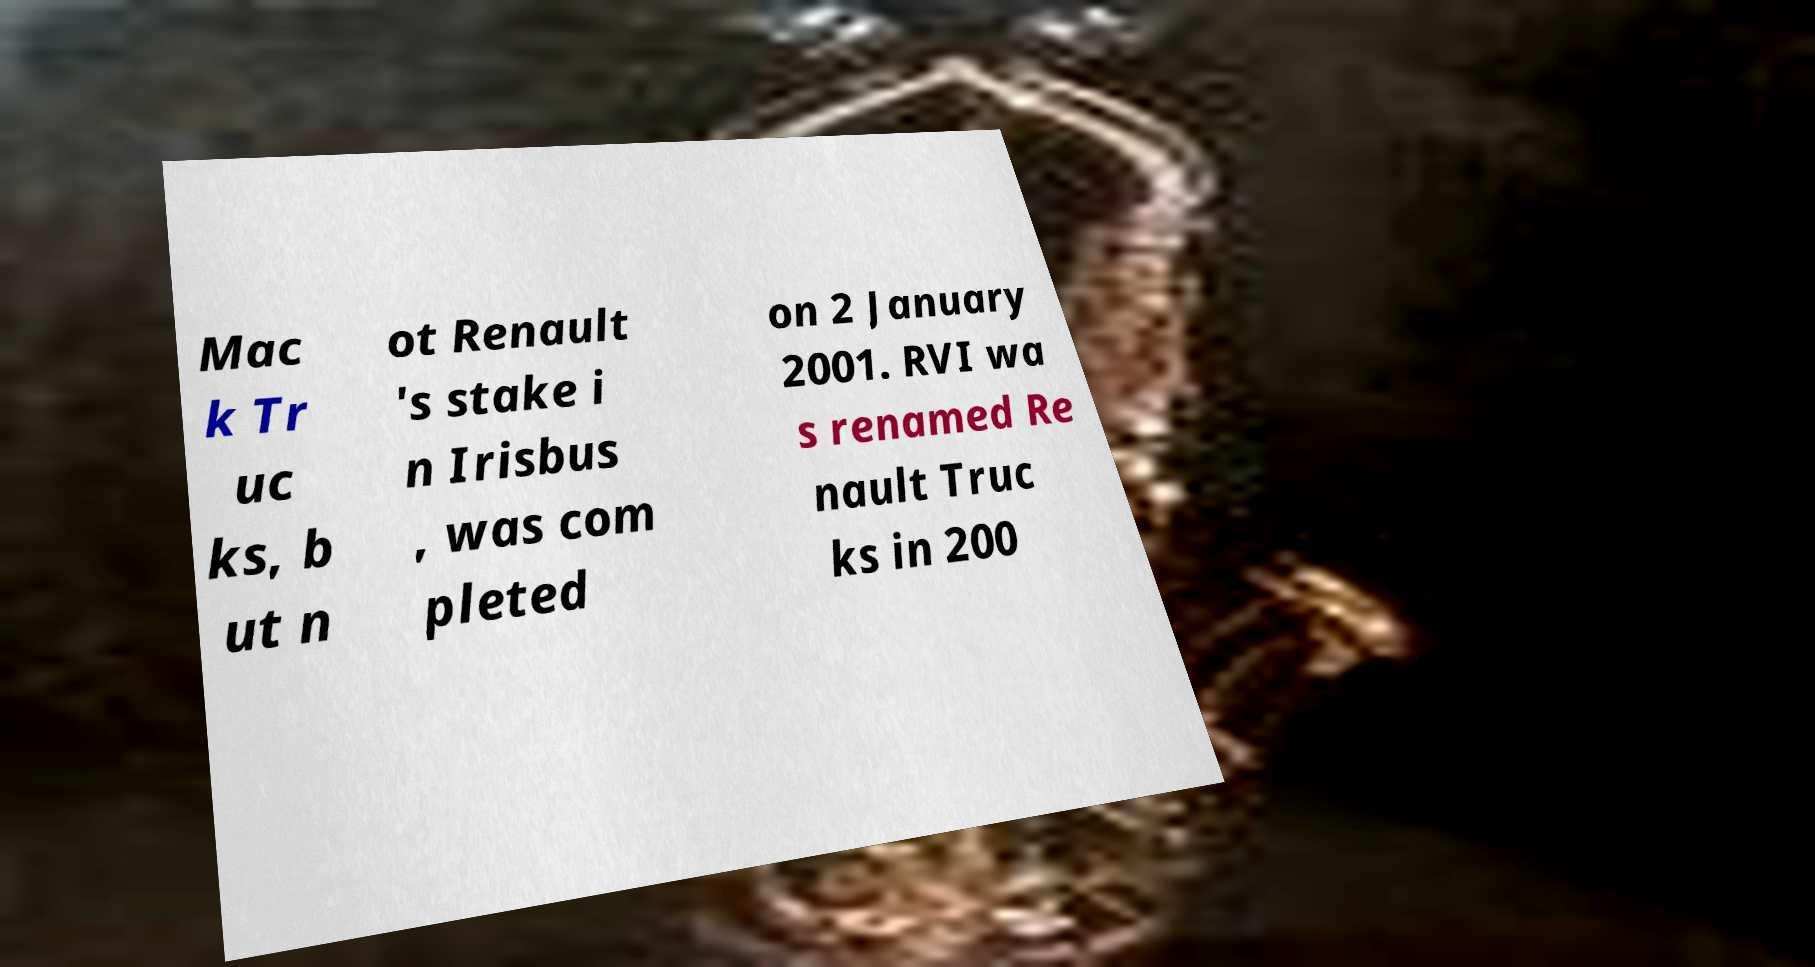What messages or text are displayed in this image? I need them in a readable, typed format. Mac k Tr uc ks, b ut n ot Renault 's stake i n Irisbus , was com pleted on 2 January 2001. RVI wa s renamed Re nault Truc ks in 200 